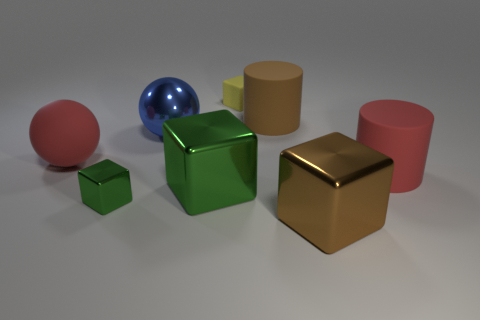There is a big rubber cylinder behind the large red rubber object on the left side of the small thing that is behind the large red cylinder; what is its color?
Keep it short and to the point. Brown. How many things are large cubes or small blocks?
Ensure brevity in your answer.  4. What number of red things have the same shape as the blue thing?
Make the answer very short. 1. Do the big red cylinder and the big cylinder that is left of the red rubber cylinder have the same material?
Your answer should be compact. Yes. The brown cylinder that is the same material as the yellow cube is what size?
Keep it short and to the point. Large. How big is the ball to the right of the tiny metal object?
Keep it short and to the point. Large. How many brown matte objects have the same size as the blue sphere?
Make the answer very short. 1. The other shiny object that is the same color as the tiny metal object is what size?
Your answer should be compact. Large. Are there any tiny balls that have the same color as the tiny rubber object?
Offer a terse response. No. The metallic ball that is the same size as the red cylinder is what color?
Make the answer very short. Blue. 